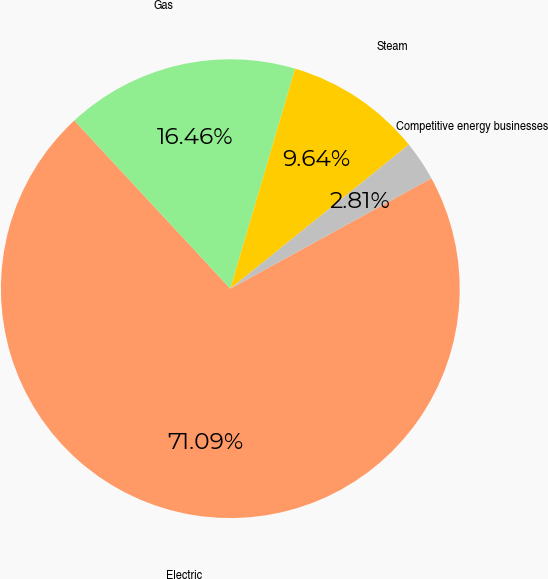Convert chart. <chart><loc_0><loc_0><loc_500><loc_500><pie_chart><fcel>Electric<fcel>Gas<fcel>Steam<fcel>Competitive energy businesses<nl><fcel>71.09%<fcel>16.46%<fcel>9.64%<fcel>2.81%<nl></chart> 